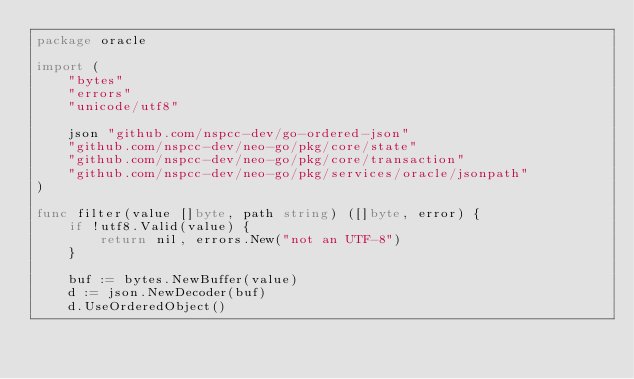Convert code to text. <code><loc_0><loc_0><loc_500><loc_500><_Go_>package oracle

import (
	"bytes"
	"errors"
	"unicode/utf8"

	json "github.com/nspcc-dev/go-ordered-json"
	"github.com/nspcc-dev/neo-go/pkg/core/state"
	"github.com/nspcc-dev/neo-go/pkg/core/transaction"
	"github.com/nspcc-dev/neo-go/pkg/services/oracle/jsonpath"
)

func filter(value []byte, path string) ([]byte, error) {
	if !utf8.Valid(value) {
		return nil, errors.New("not an UTF-8")
	}

	buf := bytes.NewBuffer(value)
	d := json.NewDecoder(buf)
	d.UseOrderedObject()
</code> 